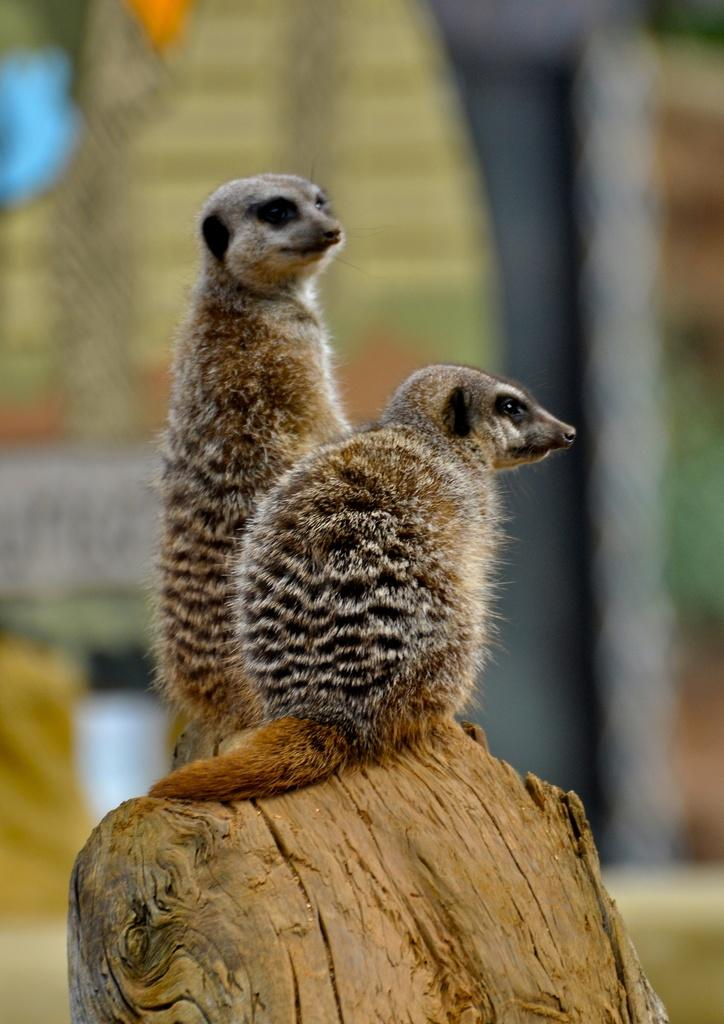What type of animals are in the image? There are meerkats in the image. Where are the meerkats located? The meerkats are on tree bark. Can you describe the background of the image? There might be a building in the background of the image. What design is the meerkat's grandmother wearing in the image? There is no mention of a grandmother or any design in the image; it features meerkats on tree bark. 